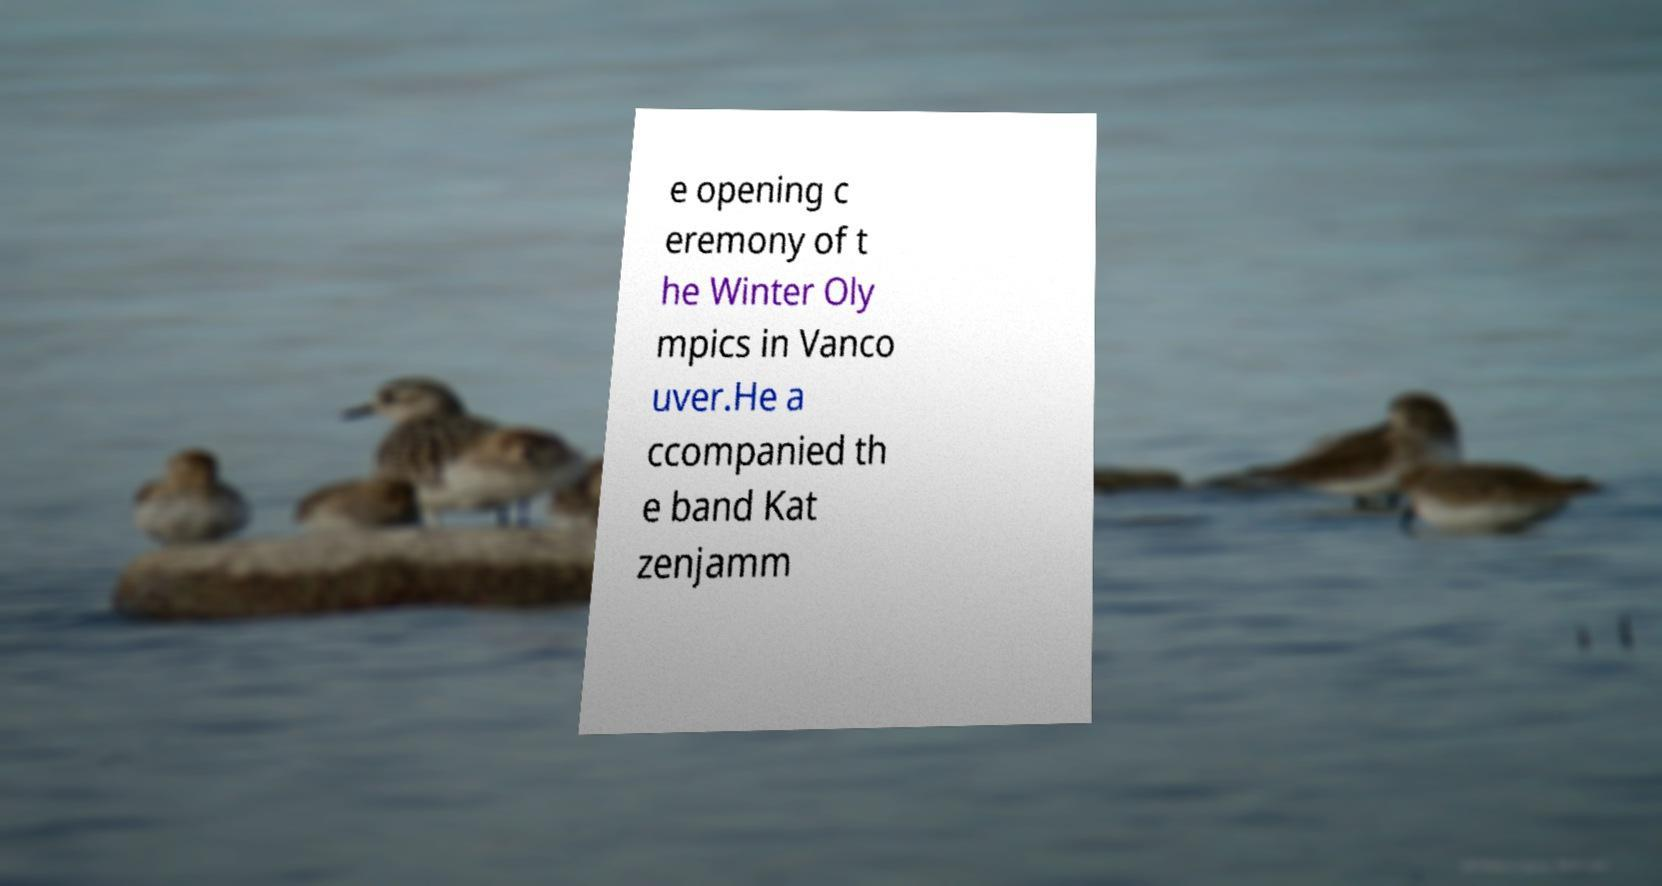For documentation purposes, I need the text within this image transcribed. Could you provide that? e opening c eremony of t he Winter Oly mpics in Vanco uver.He a ccompanied th e band Kat zenjamm 